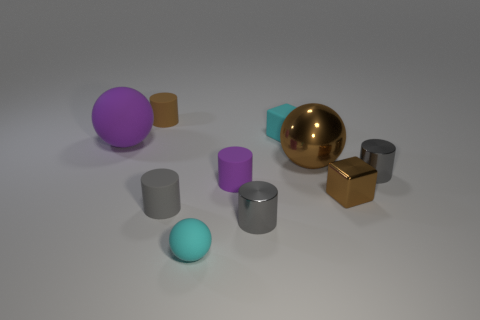Subtract all tiny brown matte cylinders. How many cylinders are left? 4 Subtract all cyan balls. How many balls are left? 2 Subtract all small cyan rubber cubes. Subtract all tiny shiny blocks. How many objects are left? 8 Add 9 tiny brown cylinders. How many tiny brown cylinders are left? 10 Add 6 small yellow metal objects. How many small yellow metal objects exist? 6 Subtract 0 yellow cylinders. How many objects are left? 10 Subtract all balls. How many objects are left? 7 Subtract 2 balls. How many balls are left? 1 Subtract all blue cubes. Subtract all red balls. How many cubes are left? 2 Subtract all green cubes. How many cyan cylinders are left? 0 